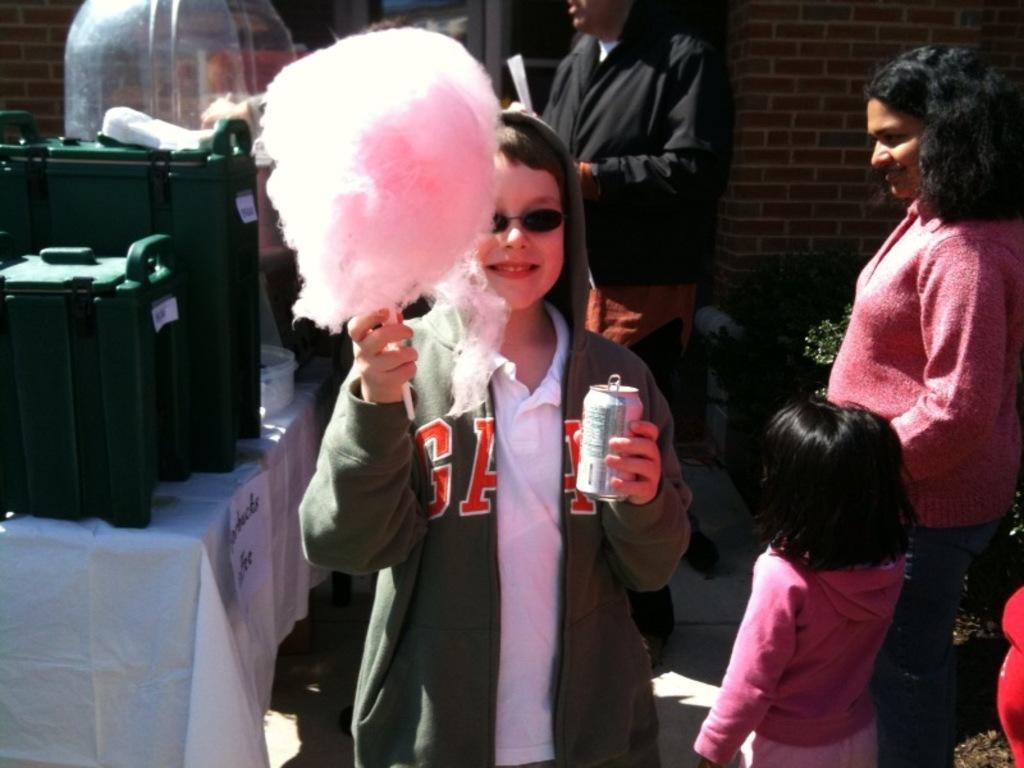Describe this image in one or two sentences. In the foreground of the picture we can see a person holding cotton candy and tin. On the left there is a table, on the table there are boxes. On the right there are women and a child. In the background there is a person in black jacket and there are plant, wall and door. 